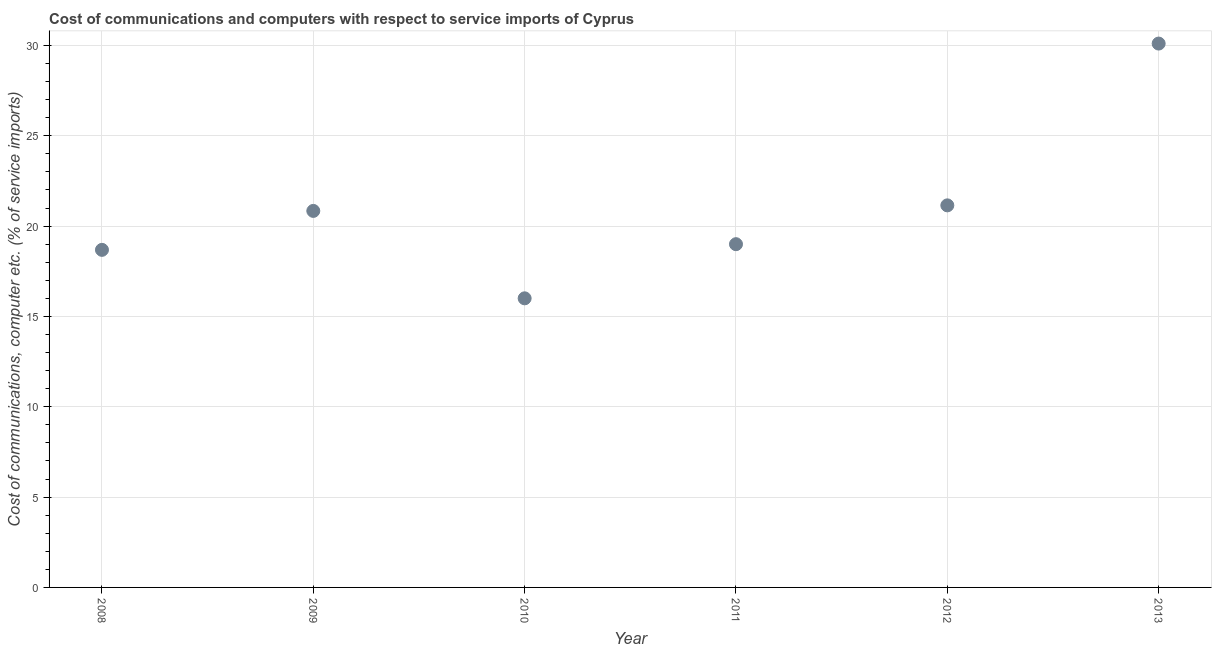What is the cost of communications and computer in 2009?
Make the answer very short. 20.84. Across all years, what is the maximum cost of communications and computer?
Ensure brevity in your answer.  30.1. Across all years, what is the minimum cost of communications and computer?
Offer a very short reply. 16. In which year was the cost of communications and computer minimum?
Your answer should be very brief. 2010. What is the sum of the cost of communications and computer?
Your answer should be compact. 125.77. What is the difference between the cost of communications and computer in 2009 and 2011?
Your answer should be very brief. 1.84. What is the average cost of communications and computer per year?
Provide a short and direct response. 20.96. What is the median cost of communications and computer?
Provide a succinct answer. 19.92. Do a majority of the years between 2011 and 2013 (inclusive) have cost of communications and computer greater than 25 %?
Ensure brevity in your answer.  No. What is the ratio of the cost of communications and computer in 2009 to that in 2010?
Provide a short and direct response. 1.3. Is the cost of communications and computer in 2008 less than that in 2009?
Provide a succinct answer. Yes. Is the difference between the cost of communications and computer in 2010 and 2011 greater than the difference between any two years?
Offer a very short reply. No. What is the difference between the highest and the second highest cost of communications and computer?
Offer a very short reply. 8.96. Is the sum of the cost of communications and computer in 2009 and 2010 greater than the maximum cost of communications and computer across all years?
Make the answer very short. Yes. What is the difference between the highest and the lowest cost of communications and computer?
Keep it short and to the point. 14.1. How many dotlines are there?
Give a very brief answer. 1. How many years are there in the graph?
Keep it short and to the point. 6. What is the difference between two consecutive major ticks on the Y-axis?
Provide a short and direct response. 5. Are the values on the major ticks of Y-axis written in scientific E-notation?
Provide a short and direct response. No. Does the graph contain grids?
Your answer should be compact. Yes. What is the title of the graph?
Keep it short and to the point. Cost of communications and computers with respect to service imports of Cyprus. What is the label or title of the X-axis?
Your answer should be very brief. Year. What is the label or title of the Y-axis?
Make the answer very short. Cost of communications, computer etc. (% of service imports). What is the Cost of communications, computer etc. (% of service imports) in 2008?
Offer a very short reply. 18.68. What is the Cost of communications, computer etc. (% of service imports) in 2009?
Ensure brevity in your answer.  20.84. What is the Cost of communications, computer etc. (% of service imports) in 2010?
Offer a terse response. 16. What is the Cost of communications, computer etc. (% of service imports) in 2011?
Offer a very short reply. 19. What is the Cost of communications, computer etc. (% of service imports) in 2012?
Ensure brevity in your answer.  21.15. What is the Cost of communications, computer etc. (% of service imports) in 2013?
Give a very brief answer. 30.1. What is the difference between the Cost of communications, computer etc. (% of service imports) in 2008 and 2009?
Your answer should be very brief. -2.16. What is the difference between the Cost of communications, computer etc. (% of service imports) in 2008 and 2010?
Offer a very short reply. 2.68. What is the difference between the Cost of communications, computer etc. (% of service imports) in 2008 and 2011?
Offer a very short reply. -0.31. What is the difference between the Cost of communications, computer etc. (% of service imports) in 2008 and 2012?
Ensure brevity in your answer.  -2.46. What is the difference between the Cost of communications, computer etc. (% of service imports) in 2008 and 2013?
Your response must be concise. -11.42. What is the difference between the Cost of communications, computer etc. (% of service imports) in 2009 and 2010?
Your answer should be compact. 4.84. What is the difference between the Cost of communications, computer etc. (% of service imports) in 2009 and 2011?
Offer a very short reply. 1.84. What is the difference between the Cost of communications, computer etc. (% of service imports) in 2009 and 2012?
Your answer should be very brief. -0.31. What is the difference between the Cost of communications, computer etc. (% of service imports) in 2009 and 2013?
Keep it short and to the point. -9.26. What is the difference between the Cost of communications, computer etc. (% of service imports) in 2010 and 2011?
Provide a succinct answer. -3. What is the difference between the Cost of communications, computer etc. (% of service imports) in 2010 and 2012?
Offer a very short reply. -5.15. What is the difference between the Cost of communications, computer etc. (% of service imports) in 2010 and 2013?
Your answer should be compact. -14.1. What is the difference between the Cost of communications, computer etc. (% of service imports) in 2011 and 2012?
Your response must be concise. -2.15. What is the difference between the Cost of communications, computer etc. (% of service imports) in 2011 and 2013?
Offer a terse response. -11.1. What is the difference between the Cost of communications, computer etc. (% of service imports) in 2012 and 2013?
Make the answer very short. -8.96. What is the ratio of the Cost of communications, computer etc. (% of service imports) in 2008 to that in 2009?
Your answer should be compact. 0.9. What is the ratio of the Cost of communications, computer etc. (% of service imports) in 2008 to that in 2010?
Provide a succinct answer. 1.17. What is the ratio of the Cost of communications, computer etc. (% of service imports) in 2008 to that in 2011?
Your response must be concise. 0.98. What is the ratio of the Cost of communications, computer etc. (% of service imports) in 2008 to that in 2012?
Keep it short and to the point. 0.88. What is the ratio of the Cost of communications, computer etc. (% of service imports) in 2008 to that in 2013?
Your answer should be very brief. 0.62. What is the ratio of the Cost of communications, computer etc. (% of service imports) in 2009 to that in 2010?
Keep it short and to the point. 1.3. What is the ratio of the Cost of communications, computer etc. (% of service imports) in 2009 to that in 2011?
Offer a very short reply. 1.1. What is the ratio of the Cost of communications, computer etc. (% of service imports) in 2009 to that in 2012?
Your answer should be very brief. 0.98. What is the ratio of the Cost of communications, computer etc. (% of service imports) in 2009 to that in 2013?
Your answer should be very brief. 0.69. What is the ratio of the Cost of communications, computer etc. (% of service imports) in 2010 to that in 2011?
Offer a very short reply. 0.84. What is the ratio of the Cost of communications, computer etc. (% of service imports) in 2010 to that in 2012?
Offer a very short reply. 0.76. What is the ratio of the Cost of communications, computer etc. (% of service imports) in 2010 to that in 2013?
Your answer should be compact. 0.53. What is the ratio of the Cost of communications, computer etc. (% of service imports) in 2011 to that in 2012?
Keep it short and to the point. 0.9. What is the ratio of the Cost of communications, computer etc. (% of service imports) in 2011 to that in 2013?
Make the answer very short. 0.63. What is the ratio of the Cost of communications, computer etc. (% of service imports) in 2012 to that in 2013?
Provide a succinct answer. 0.7. 